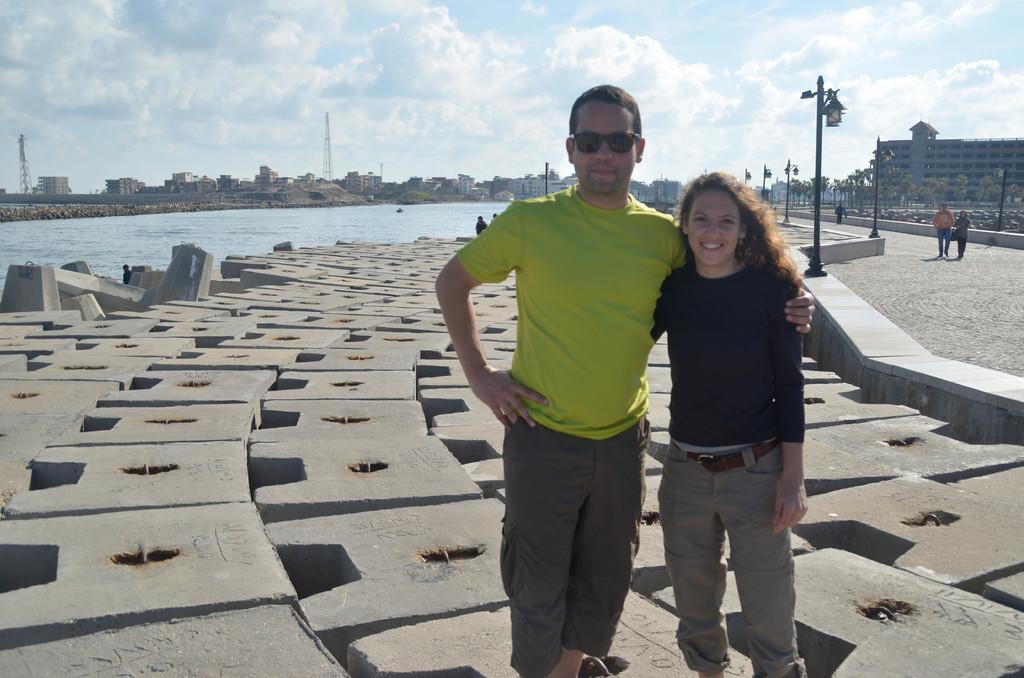How many persons are in the image? There are two persons standing in the image. What can be seen in the background of the image? There are people, lights on poles, water, buildings, trees, and the sky visible in the background of the image. What type of quarter is being used by the society in the image? There is no mention of a quarter or society in the image; it features two persons standing and various elements in the background. 